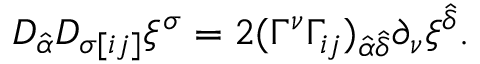Convert formula to latex. <formula><loc_0><loc_0><loc_500><loc_500>D _ { \hat { \alpha } } D _ { \sigma [ i j ] } \xi ^ { \sigma } = 2 ( \Gamma ^ { \nu } \Gamma _ { i j } ) _ { \hat { \alpha } \hat { \delta } } \partial _ { \nu } \xi ^ { \hat { \delta } } .</formula> 